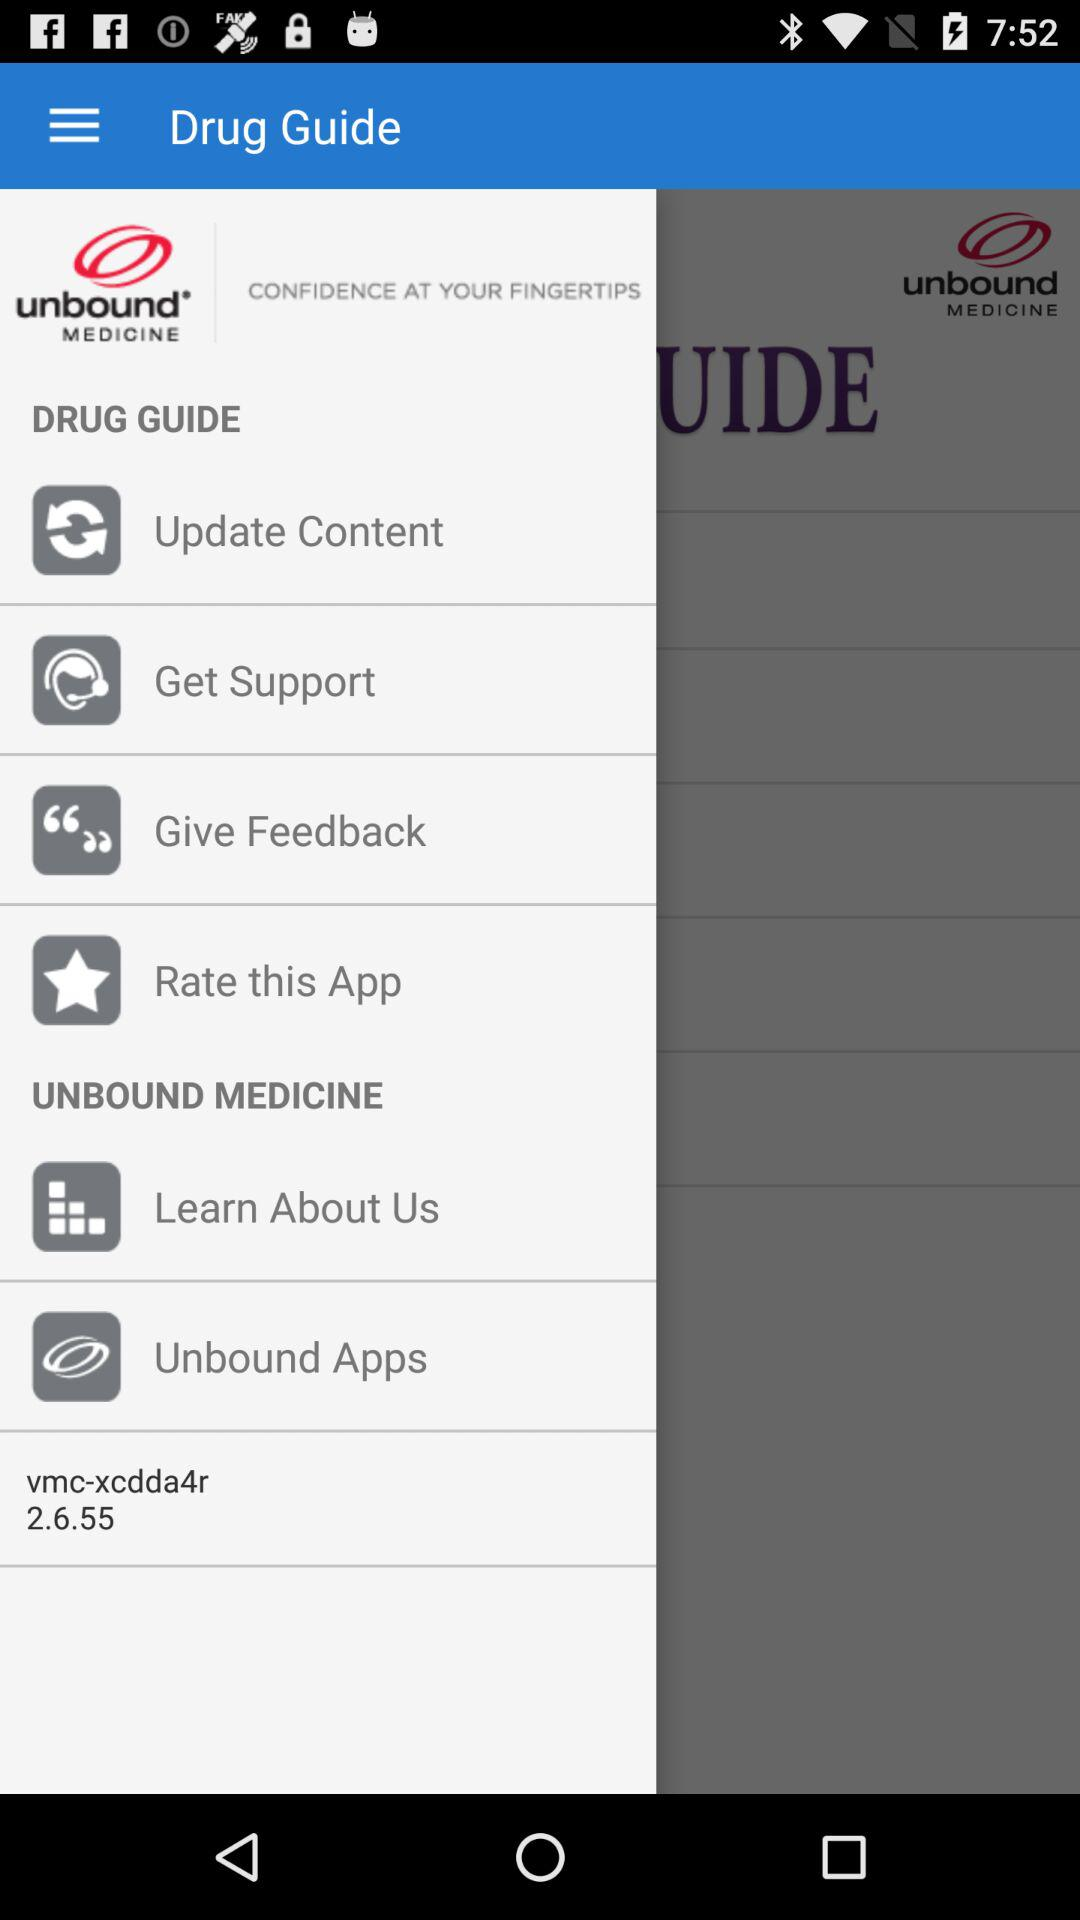What is the name of the application? The name of the application is "Drug Guide". 